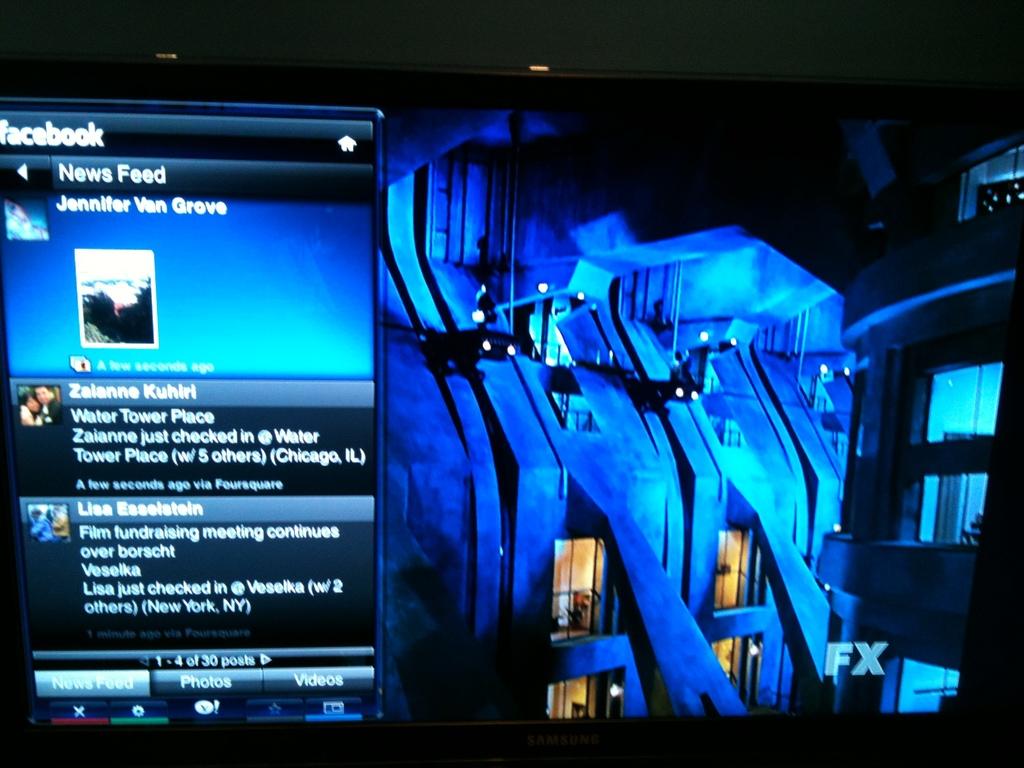What social media is mentioned?
Your response must be concise. Facebook. What is the name of the top responder?
Provide a succinct answer. Jennifer van grove. 